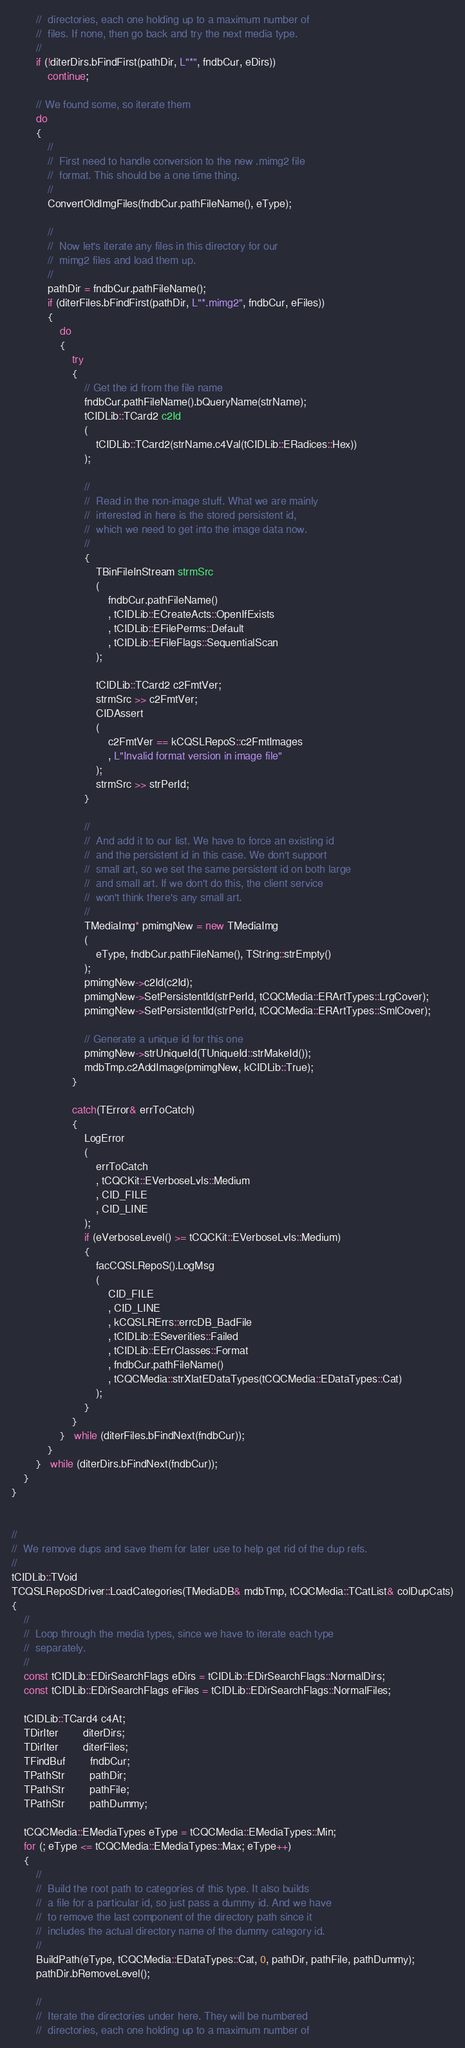<code> <loc_0><loc_0><loc_500><loc_500><_C++_>        //  directories, each one holding up to a maximum number of
        //  files. If none, then go back and try the next media type.
        //
        if (!diterDirs.bFindFirst(pathDir, L"*", fndbCur, eDirs))
            continue;

        // We found some, so iterate them
        do
        {
            //
            //  First need to handle conversion to the new .mimg2 file
            //  format. This should be a one time thing.
            //
            ConvertOldImgFiles(fndbCur.pathFileName(), eType);

            //
            //  Now let's iterate any files in this directory for our
            //  mimg2 files and load them up.
            //
            pathDir = fndbCur.pathFileName();
            if (diterFiles.bFindFirst(pathDir, L"*.mimg2", fndbCur, eFiles))
            {
                do
                {
                    try
                    {
                        // Get the id from the file name
                        fndbCur.pathFileName().bQueryName(strName);
                        tCIDLib::TCard2 c2Id
                        (
                            tCIDLib::TCard2(strName.c4Val(tCIDLib::ERadices::Hex))
                        );

                        //
                        //  Read in the non-image stuff. What we are mainly
                        //  interested in here is the stored persistent id,
                        //  which we need to get into the image data now.
                        //
                        {
                            TBinFileInStream strmSrc
                            (
                                fndbCur.pathFileName()
                                , tCIDLib::ECreateActs::OpenIfExists
                                , tCIDLib::EFilePerms::Default
                                , tCIDLib::EFileFlags::SequentialScan
                            );

                            tCIDLib::TCard2 c2FmtVer;
                            strmSrc >> c2FmtVer;
                            CIDAssert
                            (
                                c2FmtVer == kCQSLRepoS::c2FmtImages
                                , L"Invalid format version in image file"
                            );
                            strmSrc >> strPerId;
                        }

                        //
                        //  And add it to our list. We have to force an existing id
                        //  and the persistent id in this case. We don't support
                        //  small art, so we set the same persistent id on both large
                        //  and small art. If we don't do this, the client service
                        //  won't think there's any small art.
                        //
                        TMediaImg* pmimgNew = new TMediaImg
                        (
                            eType, fndbCur.pathFileName(), TString::strEmpty()
                        );
                        pmimgNew->c2Id(c2Id);
                        pmimgNew->SetPersistentId(strPerId, tCQCMedia::ERArtTypes::LrgCover);
                        pmimgNew->SetPersistentId(strPerId, tCQCMedia::ERArtTypes::SmlCover);

                        // Generate a unique id for this one
                        pmimgNew->strUniqueId(TUniqueId::strMakeId());
                        mdbTmp.c2AddImage(pmimgNew, kCIDLib::True);
                    }

                    catch(TError& errToCatch)
                    {
                        LogError
                        (
                            errToCatch
                            , tCQCKit::EVerboseLvls::Medium
                            , CID_FILE
                            , CID_LINE
                        );
                        if (eVerboseLevel() >= tCQCKit::EVerboseLvls::Medium)
                        {
                            facCQSLRepoS().LogMsg
                            (
                                CID_FILE
                                , CID_LINE
                                , kCQSLRErrs::errcDB_BadFile
                                , tCIDLib::ESeverities::Failed
                                , tCIDLib::EErrClasses::Format
                                , fndbCur.pathFileName()
                                , tCQCMedia::strXlatEDataTypes(tCQCMedia::EDataTypes::Cat)
                            );
                        }
                    }
                }   while (diterFiles.bFindNext(fndbCur));
            }
        }   while (diterDirs.bFindNext(fndbCur));
    }
}


//
//  We remove dups and save them for later use to help get rid of the dup refs.
//
tCIDLib::TVoid
TCQSLRepoSDriver::LoadCategories(TMediaDB& mdbTmp, tCQCMedia::TCatList& colDupCats)
{
    //
    //  Loop through the media types, since we have to iterate each type
    //  separately.
    //
    const tCIDLib::EDirSearchFlags eDirs = tCIDLib::EDirSearchFlags::NormalDirs;
    const tCIDLib::EDirSearchFlags eFiles = tCIDLib::EDirSearchFlags::NormalFiles;

    tCIDLib::TCard4 c4At;
    TDirIter        diterDirs;
    TDirIter        diterFiles;
    TFindBuf        fndbCur;
    TPathStr        pathDir;
    TPathStr        pathFile;
    TPathStr        pathDummy;

    tCQCMedia::EMediaTypes eType = tCQCMedia::EMediaTypes::Min;
    for (; eType <= tCQCMedia::EMediaTypes::Max; eType++)
    {
        //
        //  Build the root path to categories of this type. It also builds
        //  a file for a particular id, so just pass a dummy id. And we have
        //  to remove the last component of the directory path since it
        //  includes the actual directory name of the dummy category id.
        //
        BuildPath(eType, tCQCMedia::EDataTypes::Cat, 0, pathDir, pathFile, pathDummy);
        pathDir.bRemoveLevel();

        //
        //  Iterate the directories under here. They will be numbered
        //  directories, each one holding up to a maximum number of</code> 